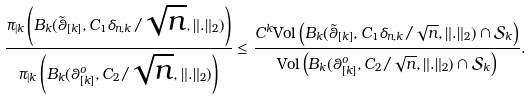Convert formula to latex. <formula><loc_0><loc_0><loc_500><loc_500>\frac { \pi _ { | k } \left ( B _ { k } ( \tilde { \theta } _ { [ k ] } , C _ { 1 } \delta _ { n , k } / \sqrt { n } , \| . \| _ { 2 } ) \right ) } { \pi _ { | k } \left ( B _ { k } ( \theta _ { [ k ] } ^ { o } , C _ { 2 } / \sqrt { n } , \| . \| _ { 2 } ) \right ) } & \leq \frac { C ^ { k } \text {Vol} \left ( B _ { k } ( \tilde { \theta } _ { [ k ] } , C _ { 1 } \delta _ { n , k } / \sqrt { n } , \| . \| _ { 2 } ) \cap \mathcal { S } _ { k } \right ) } { \text {Vol} \left ( B _ { k } ( \theta _ { [ k ] } ^ { o } , C _ { 2 } / \sqrt { n } , \| . \| _ { 2 } ) \cap \mathcal { S } _ { k } \right ) } .</formula> 